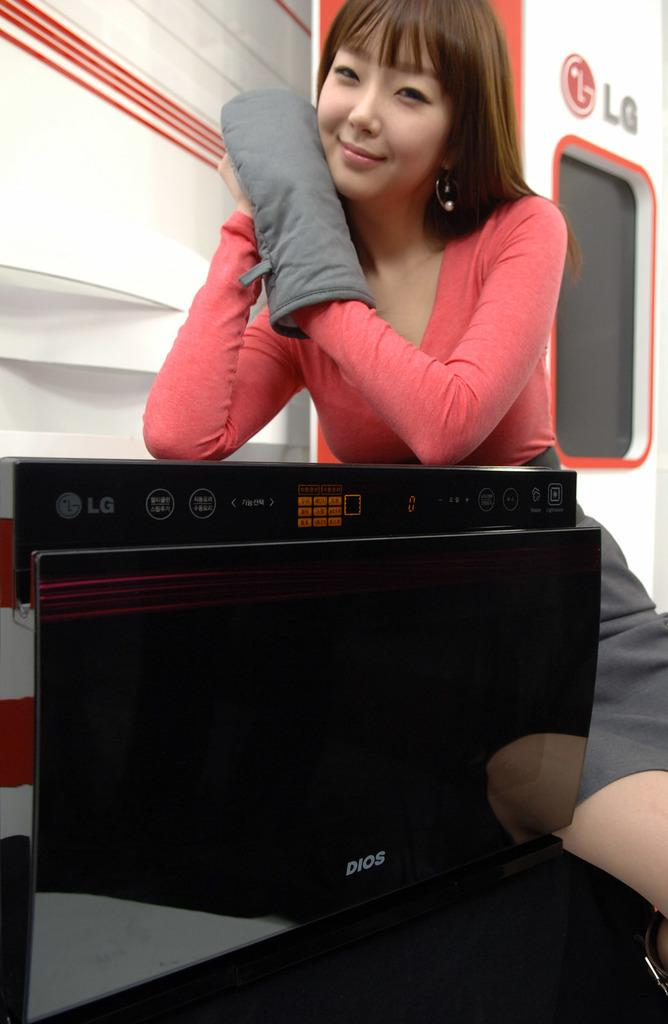<image>
Offer a succinct explanation of the picture presented. A woman sits with an LG appliance behind an LG branded door. 